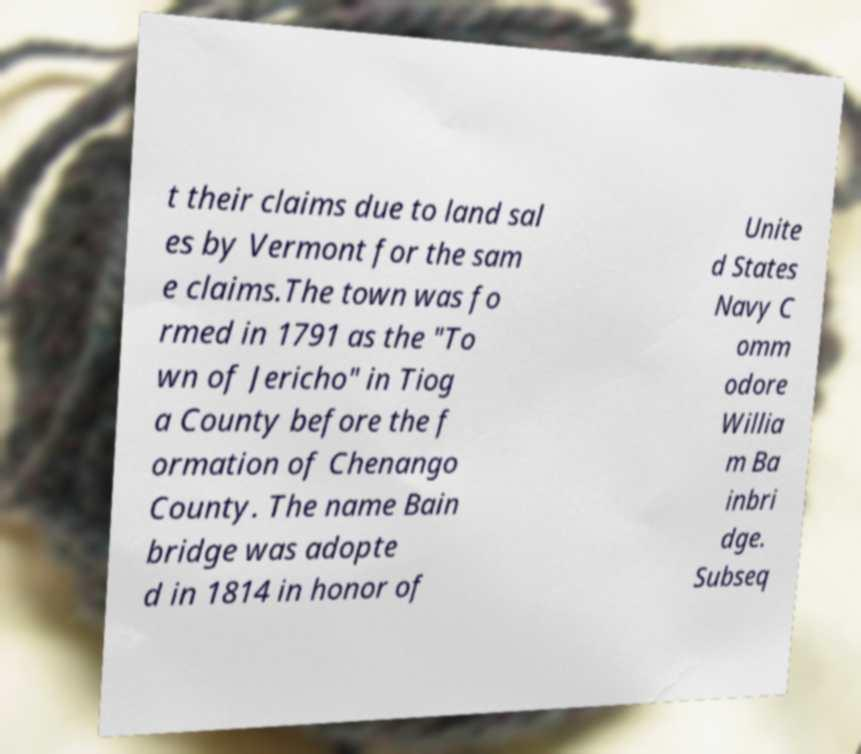Can you read and provide the text displayed in the image?This photo seems to have some interesting text. Can you extract and type it out for me? t their claims due to land sal es by Vermont for the sam e claims.The town was fo rmed in 1791 as the "To wn of Jericho" in Tiog a County before the f ormation of Chenango County. The name Bain bridge was adopte d in 1814 in honor of Unite d States Navy C omm odore Willia m Ba inbri dge. Subseq 